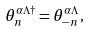Convert formula to latex. <formula><loc_0><loc_0><loc_500><loc_500>\theta _ { n } ^ { \alpha \Lambda \dagger } = \theta _ { - n } ^ { \alpha \Lambda } ,</formula> 